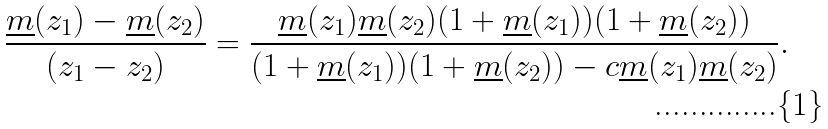<formula> <loc_0><loc_0><loc_500><loc_500>\frac { \underline { m } ( z _ { 1 } ) - \underline { m } ( z _ { 2 } ) } { ( z _ { 1 } - z _ { 2 } ) } = \frac { \underline { m } ( z _ { 1 } ) \underline { m } ( z _ { 2 } ) ( 1 + \underline { m } ( z _ { 1 } ) ) ( 1 + \underline { m } ( z _ { 2 } ) ) } { ( 1 + \underline { m } ( z _ { 1 } ) ) ( 1 + \underline { m } ( z _ { 2 } ) ) - c \underline { m } ( z _ { 1 } ) \underline { m } ( z _ { 2 } ) } .</formula> 